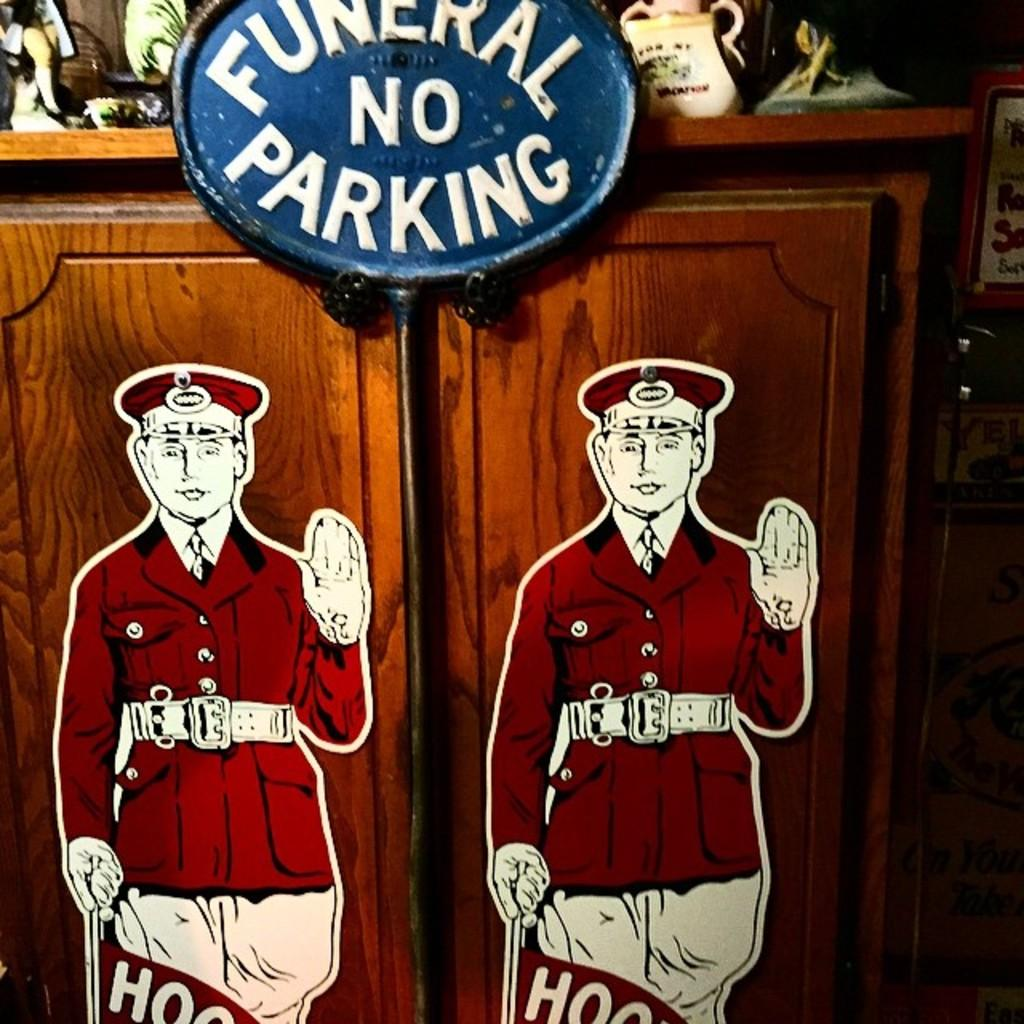<image>
Describe the image concisely. Two cartoon cut outs of a man wearing a red uniform are stuck to a wooden door below a sign that says funeral, no parking. 